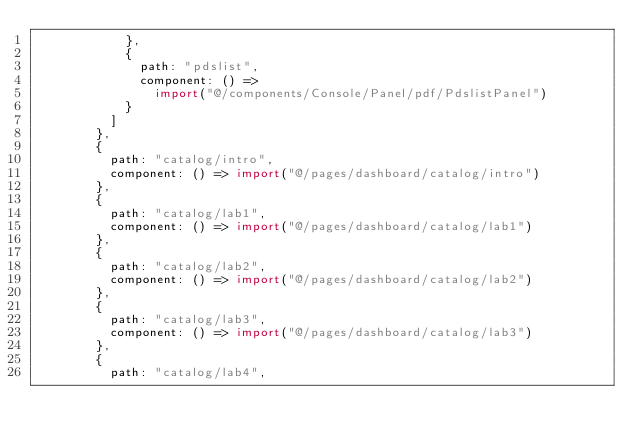Convert code to text. <code><loc_0><loc_0><loc_500><loc_500><_JavaScript_>            },
            {
              path: "pdslist",
              component: () =>
                import("@/components/Console/Panel/pdf/PdslistPanel")
            }
          ]
        },
        {
          path: "catalog/intro",
          component: () => import("@/pages/dashboard/catalog/intro")
        },
        {
          path: "catalog/lab1",
          component: () => import("@/pages/dashboard/catalog/lab1")
        },
        {
          path: "catalog/lab2",
          component: () => import("@/pages/dashboard/catalog/lab2")
        },
        {
          path: "catalog/lab3",
          component: () => import("@/pages/dashboard/catalog/lab3")
        },
        {
          path: "catalog/lab4",</code> 